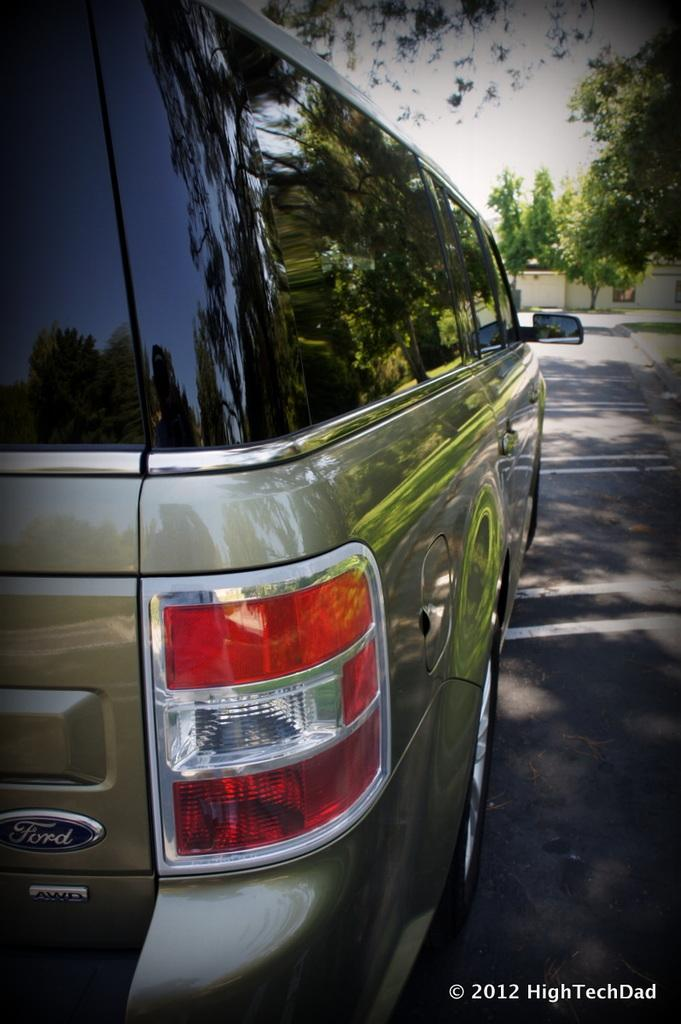What is parked on the road in the image? There is a car parked on the road in the image. What can be seen behind the car? There are trees behind the car. What structure is visible in the image? There is a wall in the image. What is visible at the top of the image? The sky is clear and visible at the top of the image. Where are the scissors located on the island in the image? There is no island or scissors present in the image. How does the car wash itself in the image? The car does not wash itself in the image; it is parked on the road. 